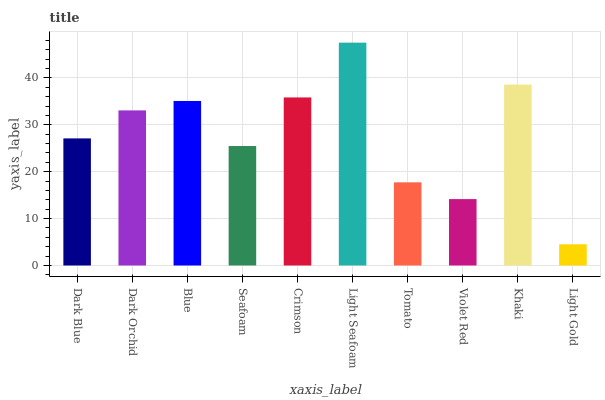Is Dark Orchid the minimum?
Answer yes or no. No. Is Dark Orchid the maximum?
Answer yes or no. No. Is Dark Orchid greater than Dark Blue?
Answer yes or no. Yes. Is Dark Blue less than Dark Orchid?
Answer yes or no. Yes. Is Dark Blue greater than Dark Orchid?
Answer yes or no. No. Is Dark Orchid less than Dark Blue?
Answer yes or no. No. Is Dark Orchid the high median?
Answer yes or no. Yes. Is Dark Blue the low median?
Answer yes or no. Yes. Is Blue the high median?
Answer yes or no. No. Is Crimson the low median?
Answer yes or no. No. 